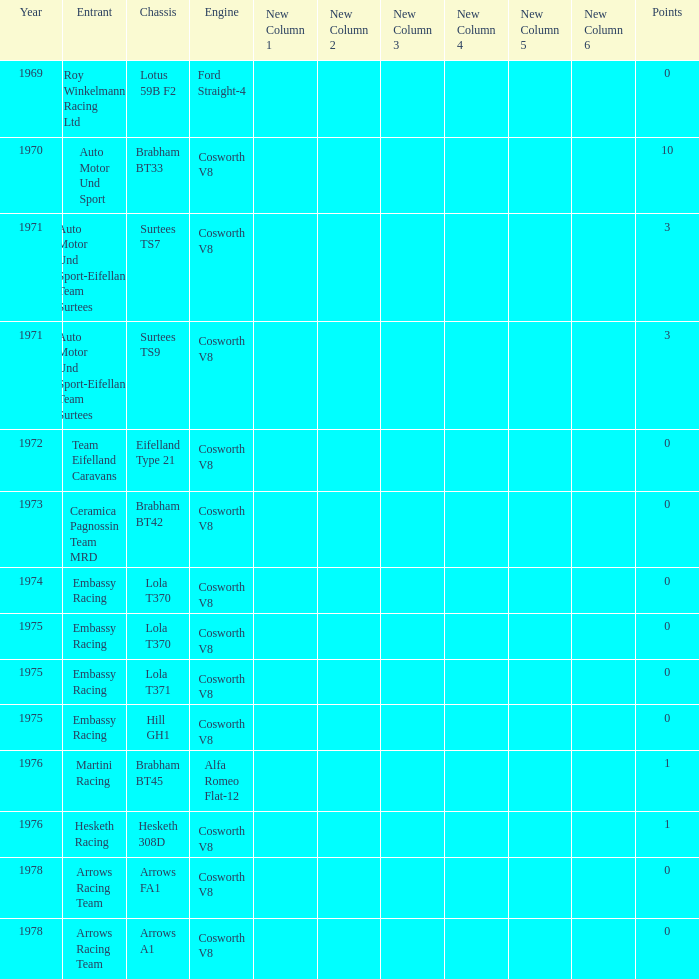What was the total amount of points in 1978 with a Chassis of arrows fa1? 0.0. 